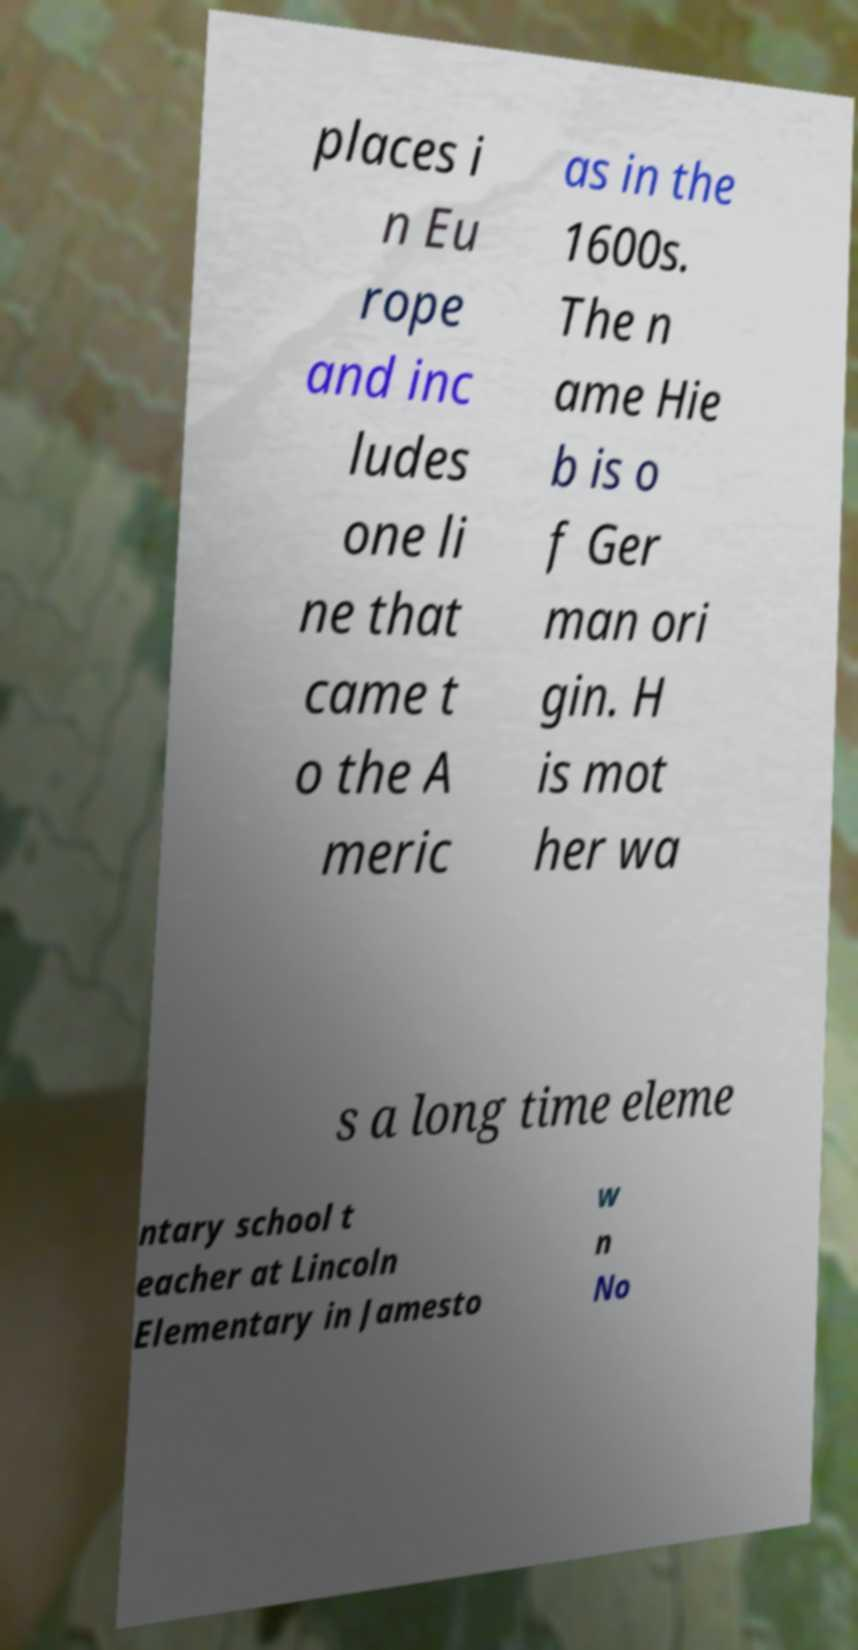Could you assist in decoding the text presented in this image and type it out clearly? places i n Eu rope and inc ludes one li ne that came t o the A meric as in the 1600s. The n ame Hie b is o f Ger man ori gin. H is mot her wa s a long time eleme ntary school t eacher at Lincoln Elementary in Jamesto w n No 